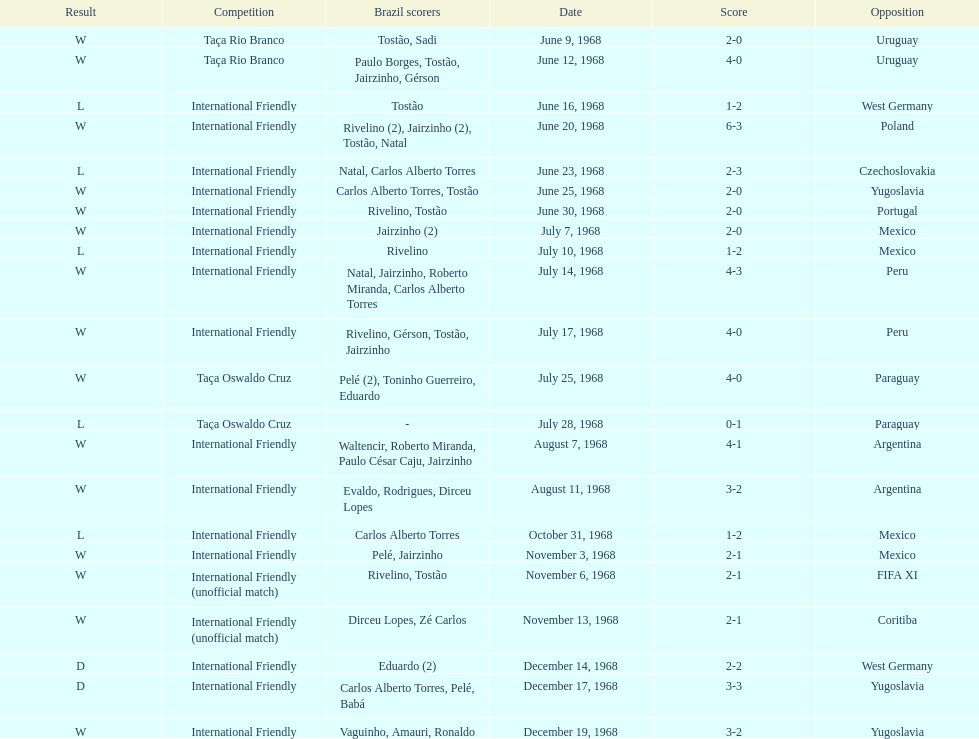What's the total number of ties? 2. 